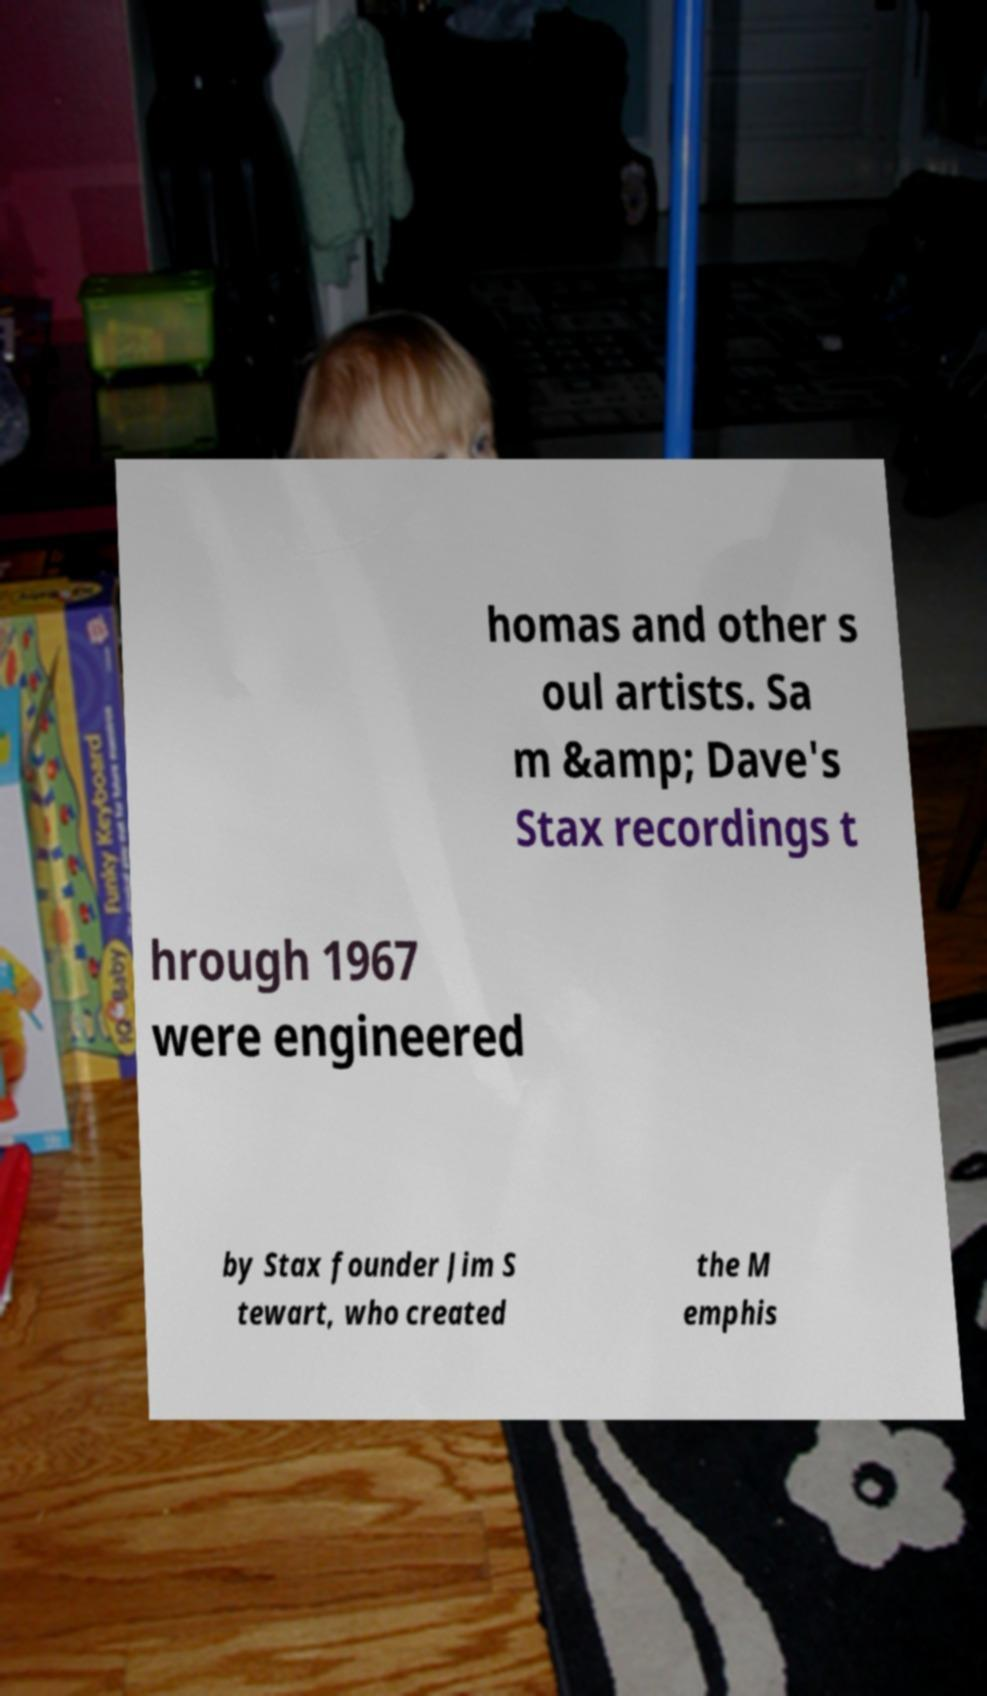Could you extract and type out the text from this image? homas and other s oul artists. Sa m &amp; Dave's Stax recordings t hrough 1967 were engineered by Stax founder Jim S tewart, who created the M emphis 